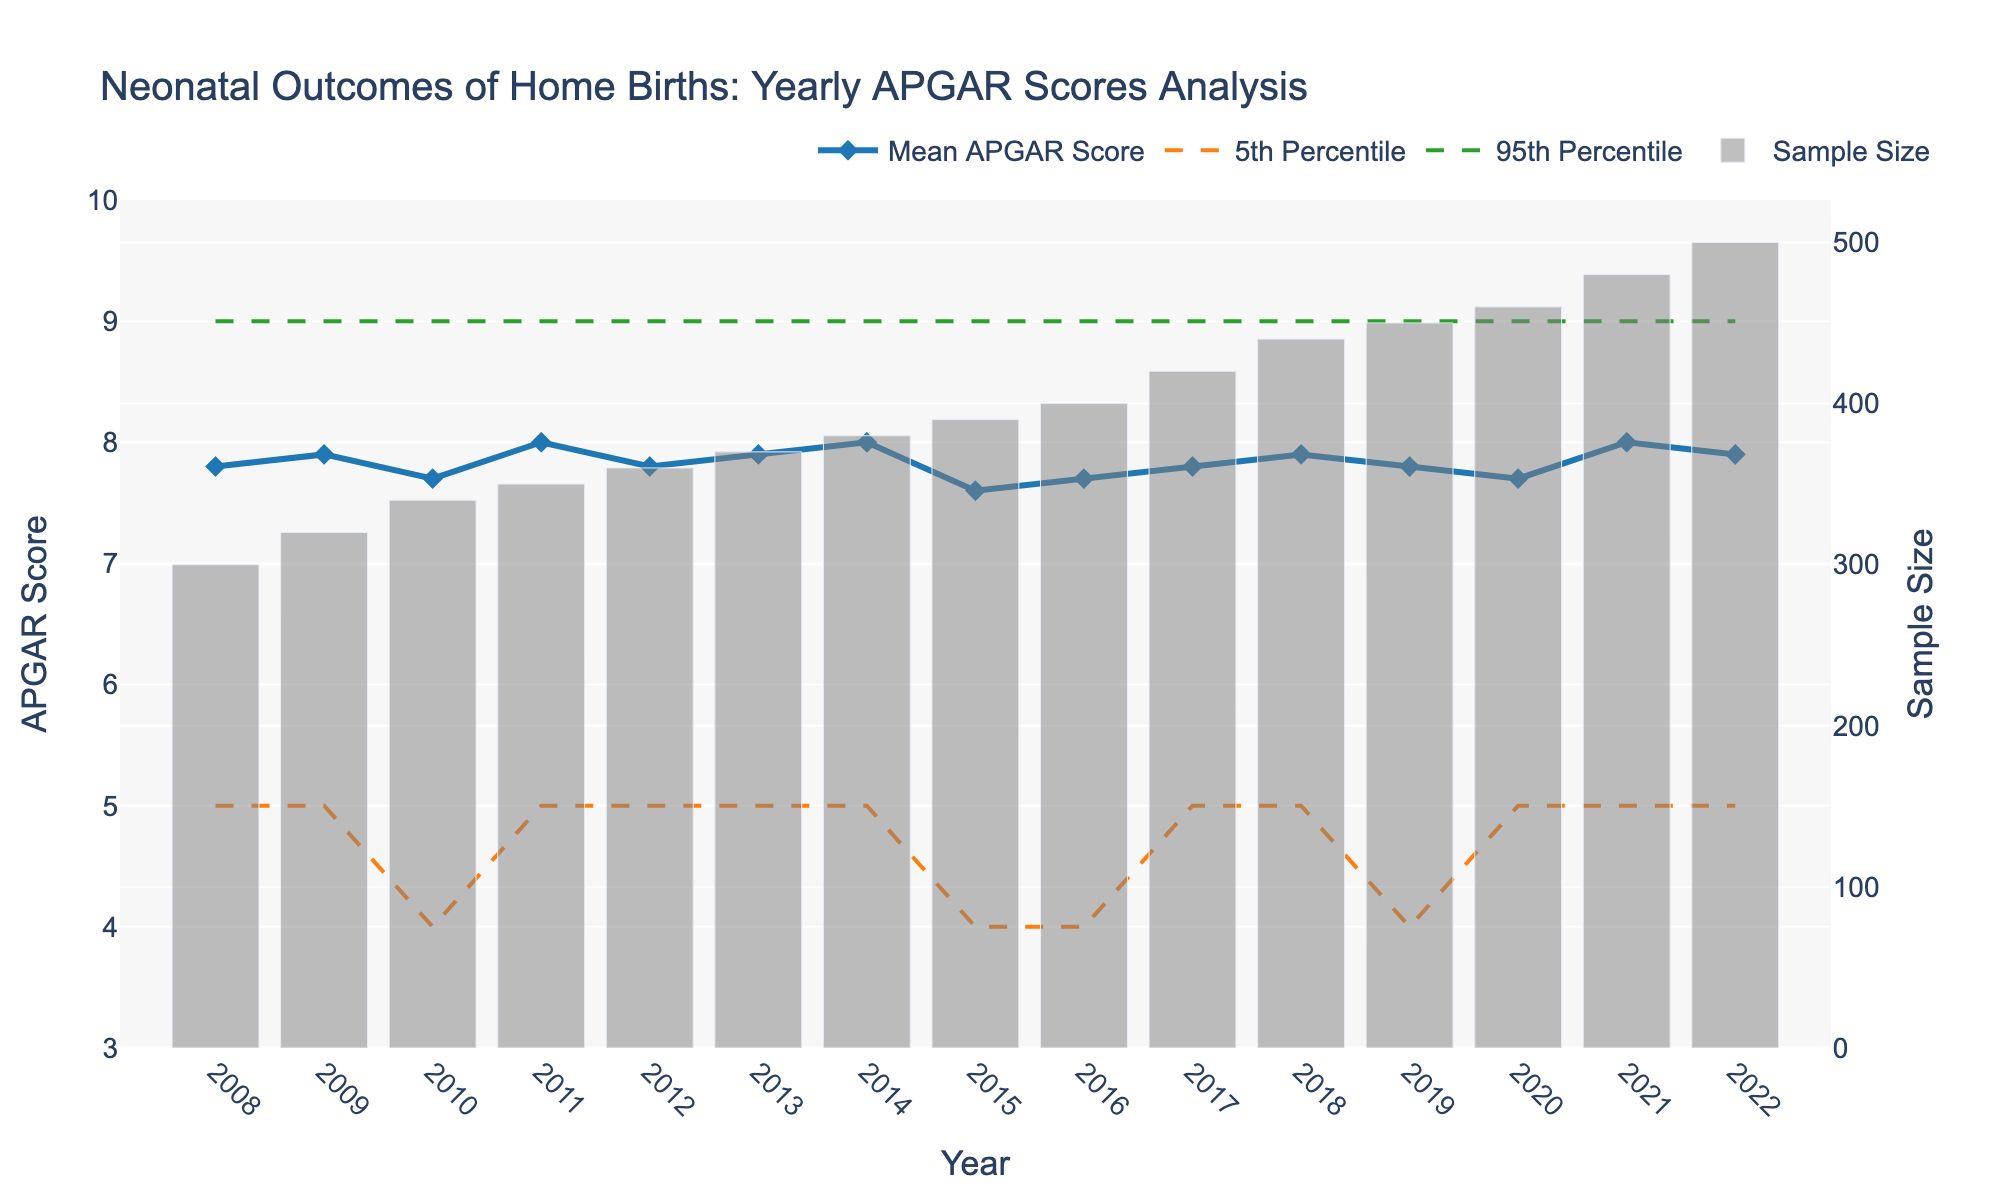How many years are covered in the analysis? The x-axis of the figure shows years ranging from 2008 to 2022. To find the number of years, subtract 2008 from 2022 and add 1 (since both 2008 and 2022 are included). Thus, 2022 - 2008 + 1 gives us 15 years.
Answer: 15 years In which year did the mean APGAR score reach its highest value? By observing the mean APGAR score line in the figure, it is clear that the highest value is reached in multiple years, specifically in 2011, 2014, and 2021, with a score of 8.0.
Answer: 2011, 2014, and 2021 What was the sample size of home births in the year with the lowest mean APGAR score? The mean APGAR score's lowest value occurs in 2015, which can be observed to be 7.6. Referring to the bar for 2015, the sample size for this year is 390.
Answer: 390 What's the difference in the 5th percentile APGAR score between 2010 and 2022? The 5th percentile APGAR score in 2010 is 4, while in 2022, it is 5. Subtract the 2010 value from the 2022 value, giving 5 - 4.
Answer: 1 Which year shows the highest 95th percentile APGAR score? Observing the 95th percentile line in the figure, the highest APGAR score is consistently 9 across all years, which means it does not change throughout the years.
Answer: All years How does the sample size trend change from 2008 to 2022? The sample size, represented by the bar graph, shows a consistent increase from 300 in 2008 to 500 in 2022.
Answer: Increasing trend What’s the difference between the mean and median APGAR scores in 2015? The mean APGAR score in 2015 is 7.6, and the median APGAR score is 7. Subtract the median from the mean, which is 7.6 - 7.
Answer: 0.6 Between 2010 and 2016, which year had the lowest mean APGAR score, and what was that score? Reviewing the mean APGAR score line, the lowest score between these years is 7.6 in 2015.
Answer: 2015, 7.6 What is the range of the APGAR scores shown in 2020? The range is found by subtracting the 5th percentile score from the 95th percentile score for 2020. The 95th percentile is 9 and the 5th percentile is 5, so 9 - 5.
Answer: 4 Is there any year where the median APGAR score deviates from 8 significantly? The median APGAR score is 8 in all years except 2015, where it is 7, providing a deviation.
Answer: 2015 